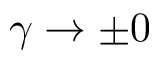Convert formula to latex. <formula><loc_0><loc_0><loc_500><loc_500>\gamma \rightarrow \pm 0</formula> 